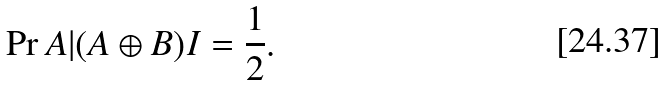<formula> <loc_0><loc_0><loc_500><loc_500>\Pr { A | ( A \oplus B ) I } = \frac { 1 } { 2 } .</formula> 